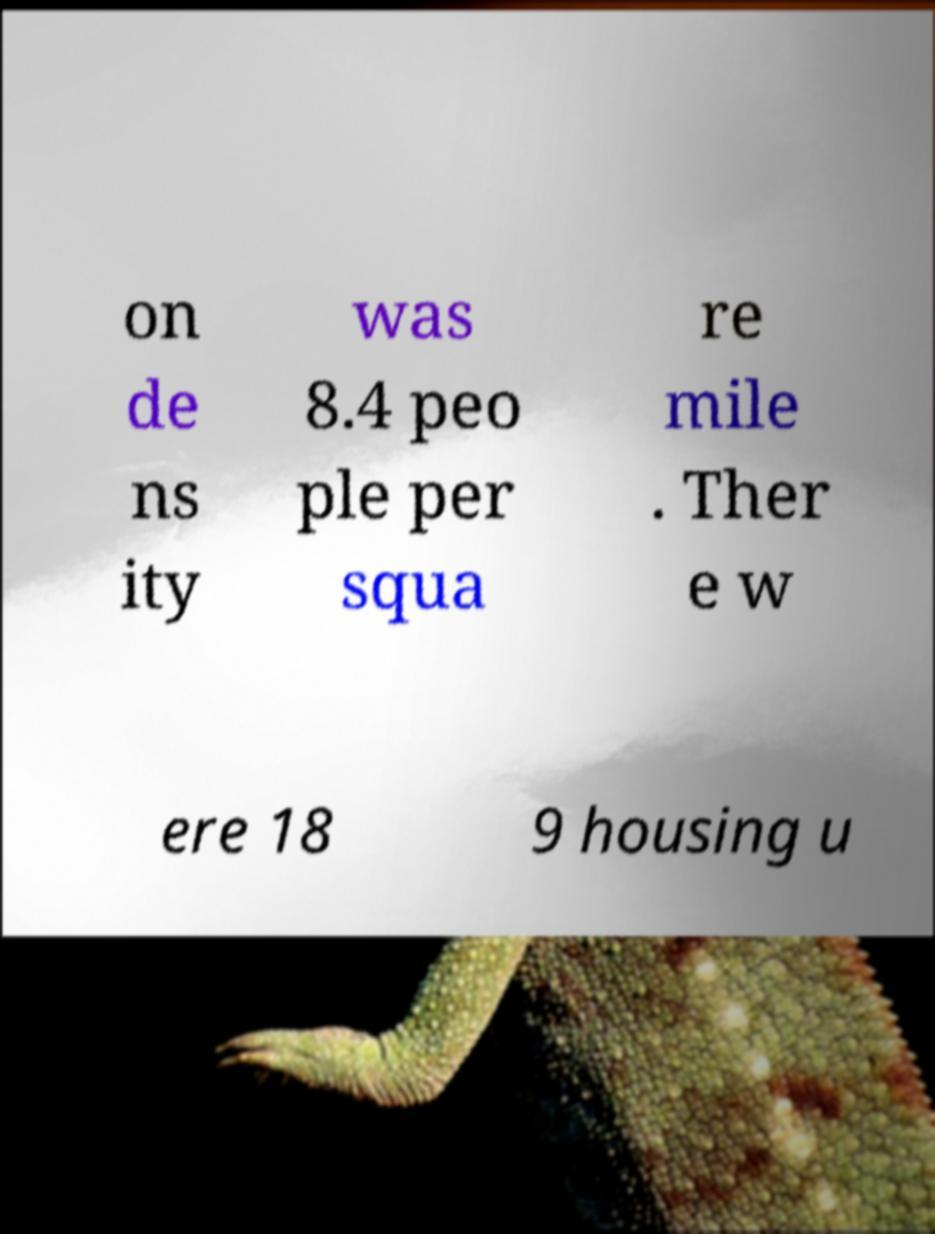Can you read and provide the text displayed in the image?This photo seems to have some interesting text. Can you extract and type it out for me? on de ns ity was 8.4 peo ple per squa re mile . Ther e w ere 18 9 housing u 